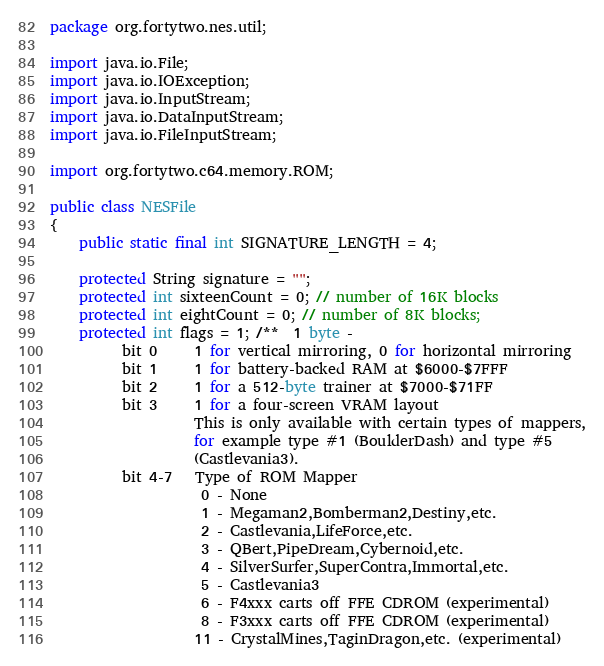<code> <loc_0><loc_0><loc_500><loc_500><_Java_>package org.fortytwo.nes.util;

import java.io.File;
import java.io.IOException;
import java.io.InputStream;
import java.io.DataInputStream;
import java.io.FileInputStream;

import org.fortytwo.c64.memory.ROM;

public class NESFile 
{
    public static final int SIGNATURE_LENGTH = 4;

    protected String signature = "";
    protected int sixteenCount = 0; // number of 16K blocks
    protected int eightCount = 0; // number of 8K blocks;
    protected int flags = 1; /**  1 byte - 
          bit 0     1 for vertical mirroring, 0 for horizontal mirroring
          bit 1     1 for battery-backed RAM at $6000-$7FFF
          bit 2     1 for a 512-byte trainer at $7000-$71FF
          bit 3     1 for a four-screen VRAM layout 
                    This is only available with certain types of mappers,
                    for example type #1 (BoulderDash) and type #5
                    (Castlevania3).
          bit 4-7   Type of ROM Mapper
                     0 - None
                     1 - Megaman2,Bomberman2,Destiny,etc.
                     2 - Castlevania,LifeForce,etc.
                     3 - QBert,PipeDream,Cybernoid,etc.
                     4 - SilverSurfer,SuperContra,Immortal,etc.
                     5 - Castlevania3
                     6 - F4xxx carts off FFE CDROM (experimental)
                     8 - F3xxx carts off FFE CDROM (experimental)
                    11 - CrystalMines,TaginDragon,etc. (experimental)</code> 